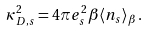<formula> <loc_0><loc_0><loc_500><loc_500>\kappa _ { D , s } ^ { 2 } = 4 \pi e _ { s } ^ { 2 } \beta \langle n _ { s } \rangle _ { \beta } \, .</formula> 